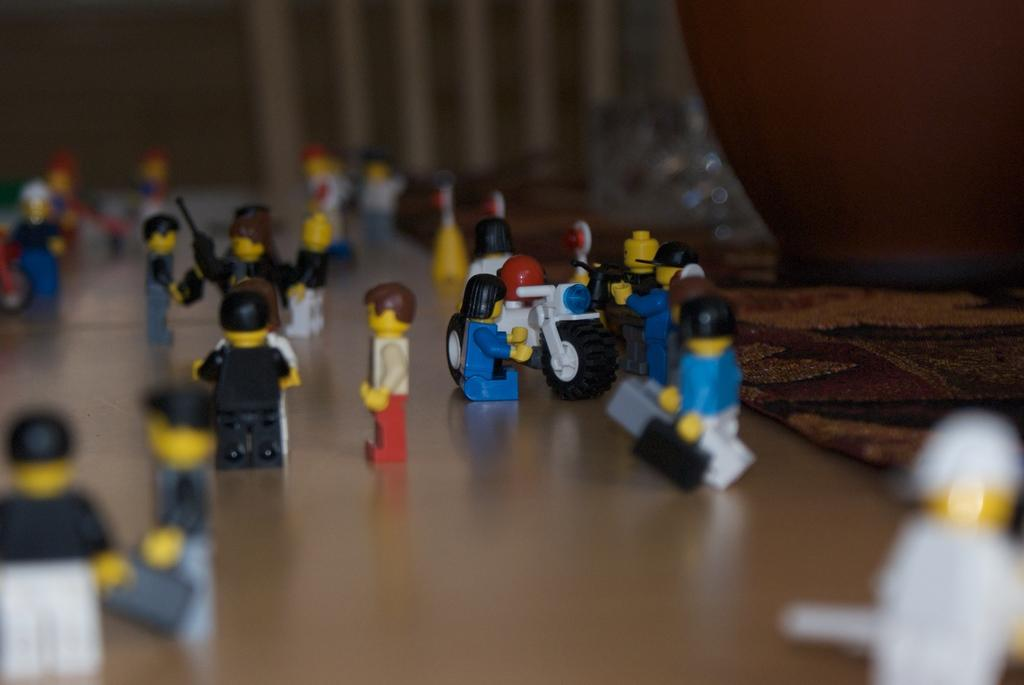What type of toys are in the image? There are Lego toys in the image. Where are the Lego toys placed? The Lego toys are on a wooden board. What can be seen in the background of the image? There is a cloth in the background of the image. What type of boat is visible in the image? There is no boat present in the image; it features Lego toys on a wooden board with a cloth in the background. 